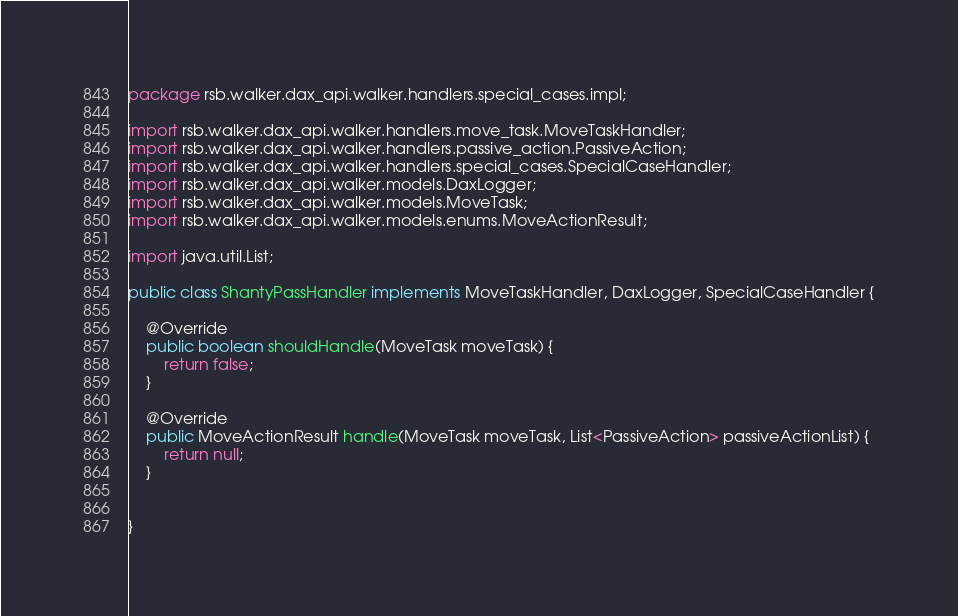Convert code to text. <code><loc_0><loc_0><loc_500><loc_500><_Java_>package rsb.walker.dax_api.walker.handlers.special_cases.impl;

import rsb.walker.dax_api.walker.handlers.move_task.MoveTaskHandler;
import rsb.walker.dax_api.walker.handlers.passive_action.PassiveAction;
import rsb.walker.dax_api.walker.handlers.special_cases.SpecialCaseHandler;
import rsb.walker.dax_api.walker.models.DaxLogger;
import rsb.walker.dax_api.walker.models.MoveTask;
import rsb.walker.dax_api.walker.models.enums.MoveActionResult;

import java.util.List;

public class ShantyPassHandler implements MoveTaskHandler, DaxLogger, SpecialCaseHandler {

    @Override
    public boolean shouldHandle(MoveTask moveTask) {
        return false;
    }

    @Override
    public MoveActionResult handle(MoveTask moveTask, List<PassiveAction> passiveActionList) {
        return null;
    }

    
}
</code> 